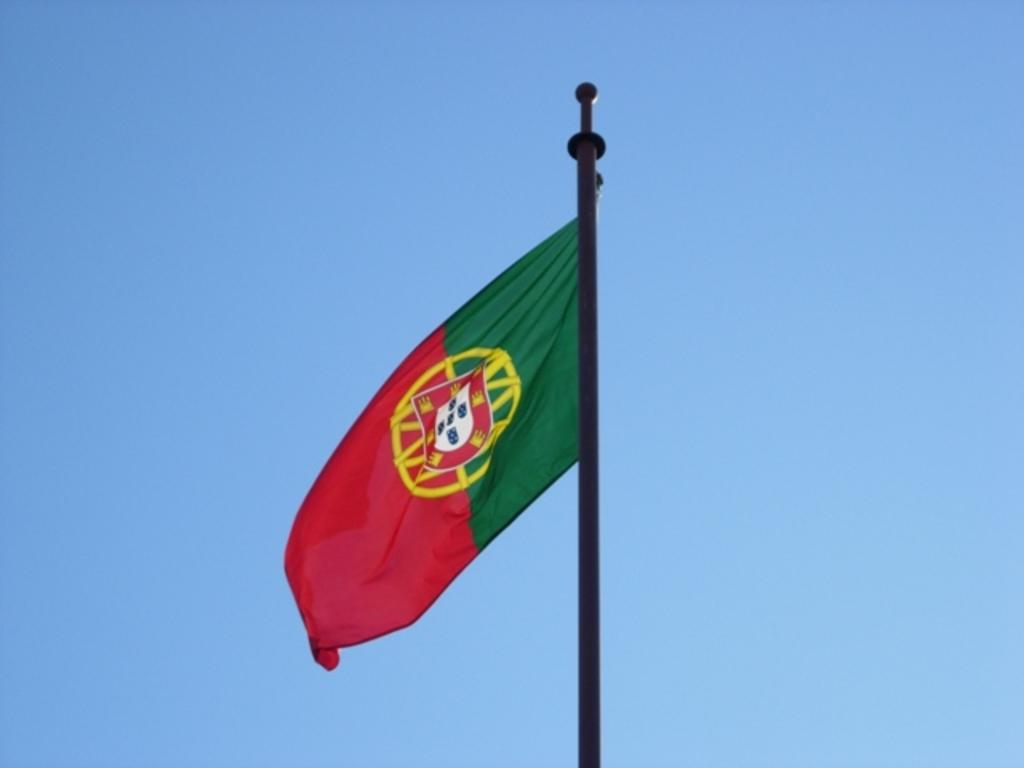What object can be seen in the image that is long and vertical? There is a pole in the image. What is attached to the top of the pole? The Portuguese flag is present on the pole. What color can be seen in the background of the image? There is a blue color visible in the background of the image. Is there any water visible in the image? There is there any bait present in the image? 